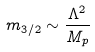<formula> <loc_0><loc_0><loc_500><loc_500>m _ { 3 / 2 } \sim \frac { \Lambda ^ { 2 } } { M _ { p } }</formula> 